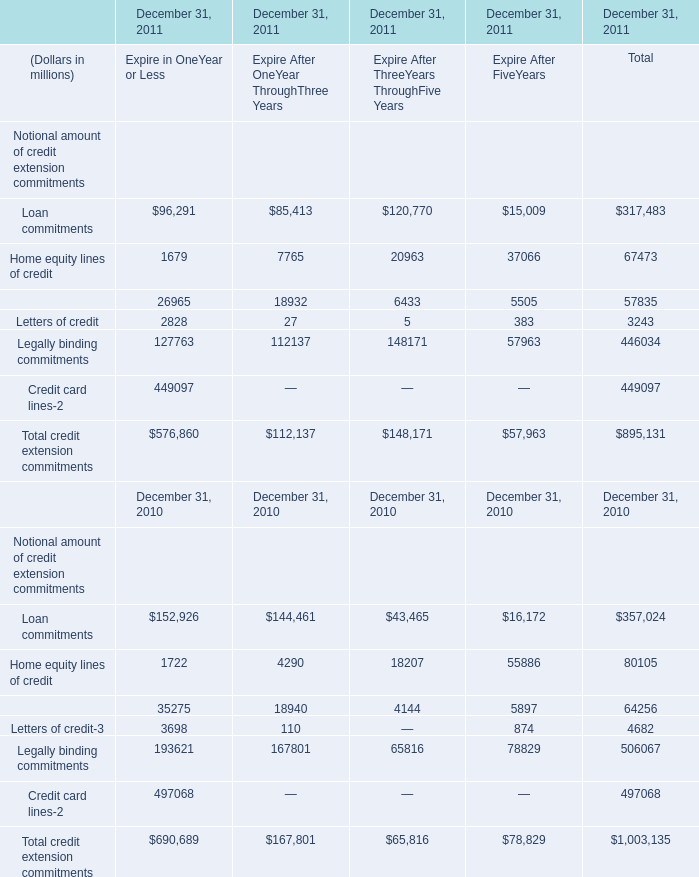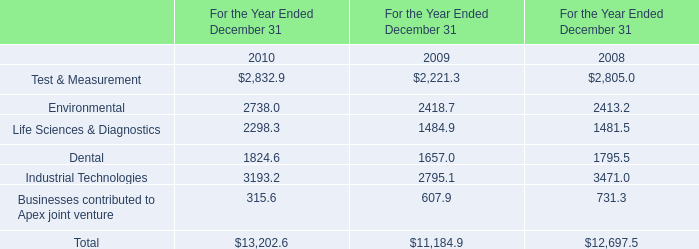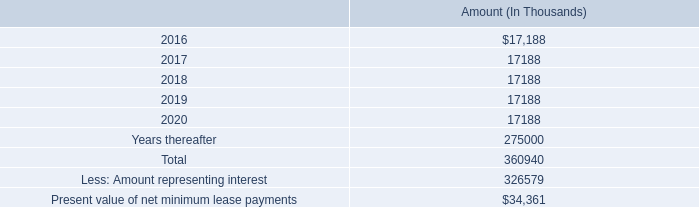In what sections is Loan commitments greater than 1 in 2011? 
Answer: Expire in OneYear or Less Expire After OneYear ThroughThree Years Expire After ThreeYears ThroughFive Years Expire After FiveYears Total. 